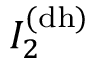Convert formula to latex. <formula><loc_0><loc_0><loc_500><loc_500>I _ { 2 } ^ { ( d h ) }</formula> 